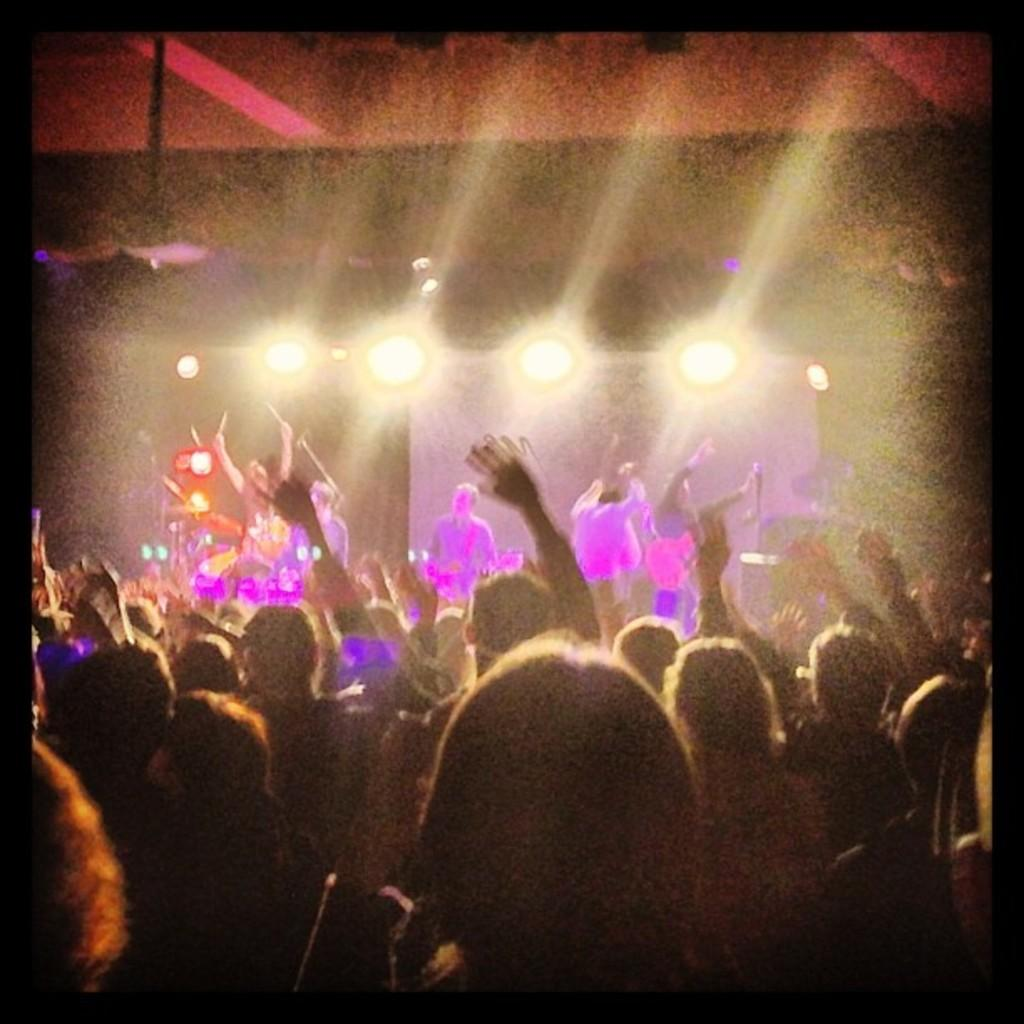What are the people in the image doing? The people in the image are playing musical instruments. Are there any other people in the image besides those playing instruments? Yes, there are people standing in the image. What can be seen in the image that provides illumination? Lights are visible in the image. What is the format of the image? The image has borders. What type of brain development can be observed in the image? There is no reference to brain development in the image; it features people playing musical instruments and standing. Can you tell me what kind of pen is being used by the people in the image? There is no pen present in the image. 